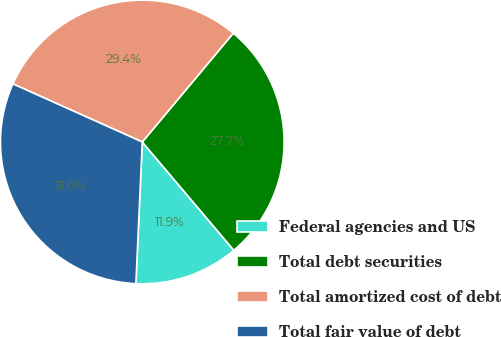<chart> <loc_0><loc_0><loc_500><loc_500><pie_chart><fcel>Federal agencies and US<fcel>Total debt securities<fcel>Total amortized cost of debt<fcel>Total fair value of debt<nl><fcel>11.89%<fcel>27.74%<fcel>29.37%<fcel>31.0%<nl></chart> 